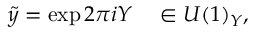Convert formula to latex. <formula><loc_0><loc_0><loc_500><loc_500>\tilde { y } = \exp 2 \pi i Y \quad i n U ( 1 ) _ { Y } ,</formula> 